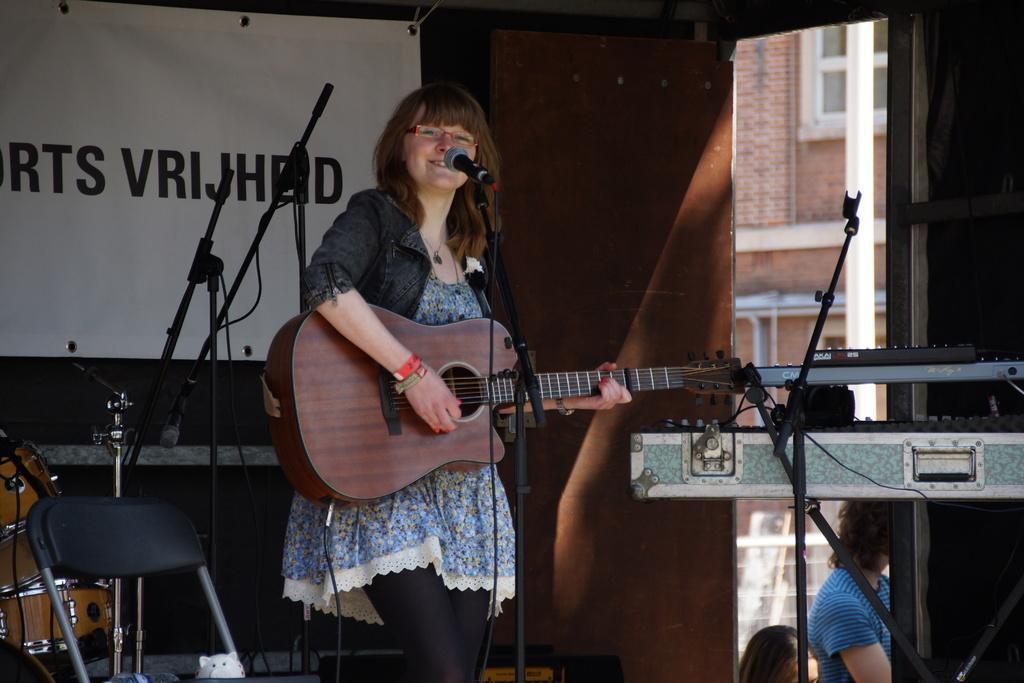In one or two sentences, can you explain what this image depicts? This is the picture of a lady who is holding a guitar and playing it in front of the mic and beside her there is a musical instrument and a chair and a mic. 